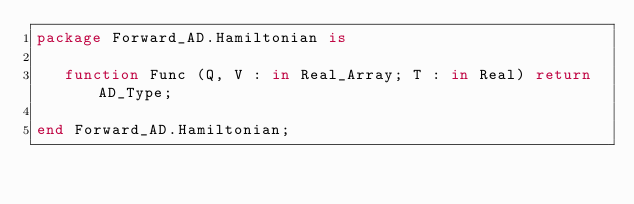<code> <loc_0><loc_0><loc_500><loc_500><_Ada_>package Forward_AD.Hamiltonian is
   
   function Func (Q, V : in Real_Array; T : in Real) return AD_Type;
   
end Forward_AD.Hamiltonian;
</code> 